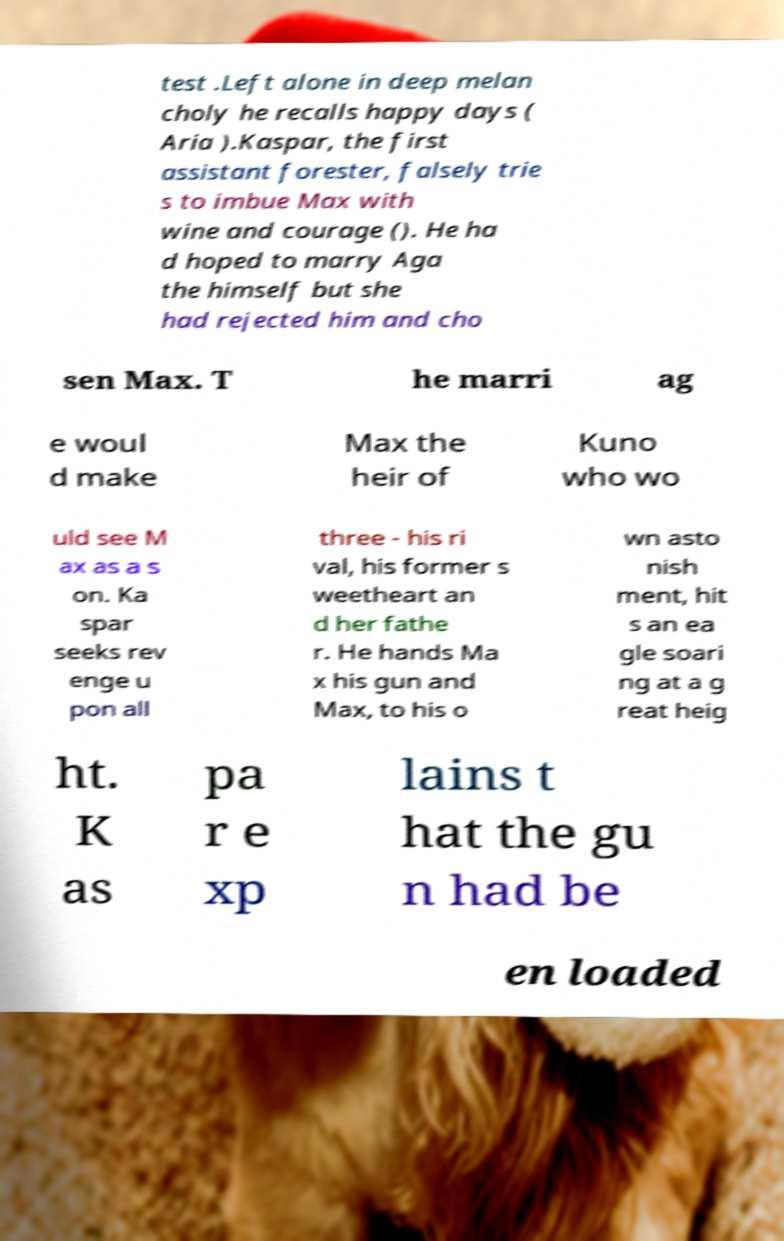Can you accurately transcribe the text from the provided image for me? test .Left alone in deep melan choly he recalls happy days ( Aria ).Kaspar, the first assistant forester, falsely trie s to imbue Max with wine and courage (). He ha d hoped to marry Aga the himself but she had rejected him and cho sen Max. T he marri ag e woul d make Max the heir of Kuno who wo uld see M ax as a s on. Ka spar seeks rev enge u pon all three - his ri val, his former s weetheart an d her fathe r. He hands Ma x his gun and Max, to his o wn asto nish ment, hit s an ea gle soari ng at a g reat heig ht. K as pa r e xp lains t hat the gu n had be en loaded 